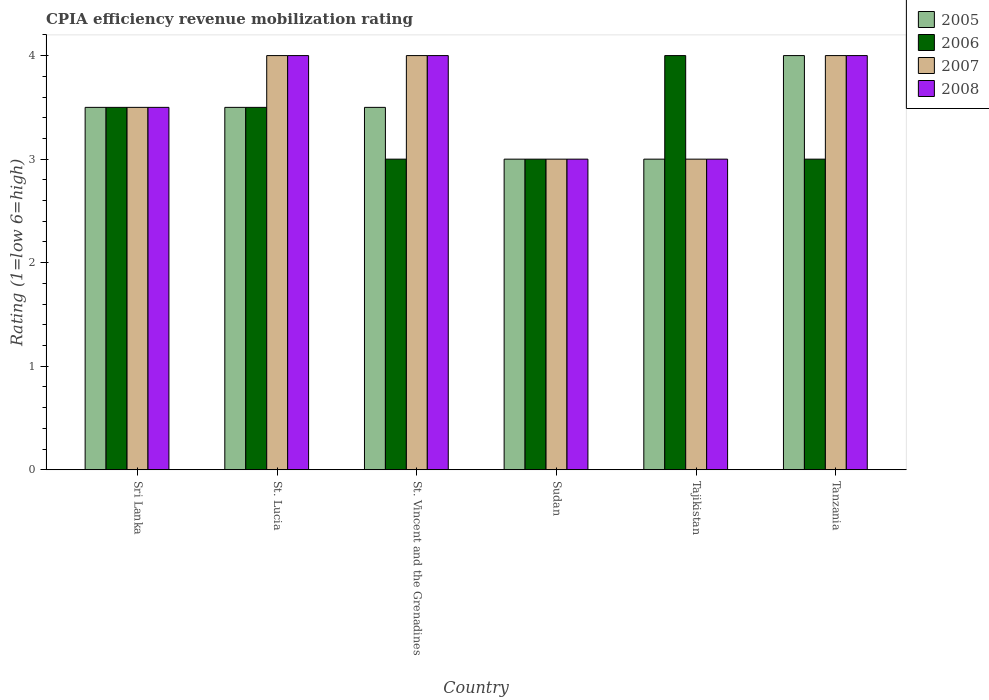Are the number of bars on each tick of the X-axis equal?
Give a very brief answer. Yes. How many bars are there on the 4th tick from the right?
Provide a short and direct response. 4. What is the label of the 2nd group of bars from the left?
Make the answer very short. St. Lucia. In which country was the CPIA rating in 2006 maximum?
Your answer should be very brief. Tajikistan. In which country was the CPIA rating in 2008 minimum?
Give a very brief answer. Sudan. What is the total CPIA rating in 2007 in the graph?
Offer a very short reply. 21.5. What is the difference between the CPIA rating in 2006 in Tajikistan and that in Tanzania?
Give a very brief answer. 1. What is the difference between the CPIA rating in 2005 in Sudan and the CPIA rating in 2008 in Sri Lanka?
Your answer should be compact. -0.5. What is the average CPIA rating in 2008 per country?
Offer a terse response. 3.58. What is the difference between the CPIA rating of/in 2006 and CPIA rating of/in 2007 in Sri Lanka?
Provide a short and direct response. 0. In how many countries, is the CPIA rating in 2006 greater than 2.4?
Make the answer very short. 6. Is the CPIA rating in 2008 in St. Lucia less than that in Tajikistan?
Offer a very short reply. No. Is the difference between the CPIA rating in 2006 in Sudan and Tajikistan greater than the difference between the CPIA rating in 2007 in Sudan and Tajikistan?
Your answer should be very brief. No. What is the difference between the highest and the second highest CPIA rating in 2005?
Make the answer very short. -0.5. What is the difference between the highest and the lowest CPIA rating in 2008?
Give a very brief answer. 1. What does the 3rd bar from the left in St. Vincent and the Grenadines represents?
Give a very brief answer. 2007. How many bars are there?
Ensure brevity in your answer.  24. Does the graph contain any zero values?
Ensure brevity in your answer.  No. Does the graph contain grids?
Offer a very short reply. No. How many legend labels are there?
Offer a very short reply. 4. How are the legend labels stacked?
Offer a terse response. Vertical. What is the title of the graph?
Provide a succinct answer. CPIA efficiency revenue mobilization rating. What is the label or title of the Y-axis?
Make the answer very short. Rating (1=low 6=high). What is the Rating (1=low 6=high) in 2006 in Sri Lanka?
Give a very brief answer. 3.5. What is the Rating (1=low 6=high) in 2008 in Sri Lanka?
Ensure brevity in your answer.  3.5. What is the Rating (1=low 6=high) in 2005 in St. Lucia?
Ensure brevity in your answer.  3.5. What is the Rating (1=low 6=high) of 2006 in St. Lucia?
Keep it short and to the point. 3.5. What is the Rating (1=low 6=high) of 2005 in St. Vincent and the Grenadines?
Offer a terse response. 3.5. What is the Rating (1=low 6=high) in 2006 in St. Vincent and the Grenadines?
Make the answer very short. 3. What is the Rating (1=low 6=high) of 2007 in St. Vincent and the Grenadines?
Make the answer very short. 4. What is the Rating (1=low 6=high) in 2007 in Sudan?
Offer a very short reply. 3. What is the Rating (1=low 6=high) of 2005 in Tajikistan?
Give a very brief answer. 3. What is the Rating (1=low 6=high) in 2005 in Tanzania?
Your answer should be very brief. 4. Across all countries, what is the minimum Rating (1=low 6=high) in 2005?
Offer a very short reply. 3. Across all countries, what is the minimum Rating (1=low 6=high) of 2007?
Provide a short and direct response. 3. Across all countries, what is the minimum Rating (1=low 6=high) in 2008?
Your answer should be compact. 3. What is the total Rating (1=low 6=high) in 2005 in the graph?
Your answer should be compact. 20.5. What is the total Rating (1=low 6=high) in 2006 in the graph?
Offer a very short reply. 20. What is the difference between the Rating (1=low 6=high) in 2005 in Sri Lanka and that in St. Lucia?
Provide a succinct answer. 0. What is the difference between the Rating (1=low 6=high) in 2005 in Sri Lanka and that in St. Vincent and the Grenadines?
Provide a succinct answer. 0. What is the difference between the Rating (1=low 6=high) in 2008 in Sri Lanka and that in St. Vincent and the Grenadines?
Offer a very short reply. -0.5. What is the difference between the Rating (1=low 6=high) in 2006 in Sri Lanka and that in Sudan?
Provide a succinct answer. 0.5. What is the difference between the Rating (1=low 6=high) in 2007 in Sri Lanka and that in Sudan?
Provide a succinct answer. 0.5. What is the difference between the Rating (1=low 6=high) of 2006 in Sri Lanka and that in Tajikistan?
Provide a succinct answer. -0.5. What is the difference between the Rating (1=low 6=high) of 2005 in Sri Lanka and that in Tanzania?
Offer a terse response. -0.5. What is the difference between the Rating (1=low 6=high) in 2006 in Sri Lanka and that in Tanzania?
Provide a short and direct response. 0.5. What is the difference between the Rating (1=low 6=high) of 2008 in Sri Lanka and that in Tanzania?
Your response must be concise. -0.5. What is the difference between the Rating (1=low 6=high) in 2006 in St. Lucia and that in St. Vincent and the Grenadines?
Your answer should be compact. 0.5. What is the difference between the Rating (1=low 6=high) of 2007 in St. Lucia and that in St. Vincent and the Grenadines?
Your answer should be compact. 0. What is the difference between the Rating (1=low 6=high) in 2005 in St. Lucia and that in Sudan?
Your answer should be compact. 0.5. What is the difference between the Rating (1=low 6=high) of 2007 in St. Lucia and that in Sudan?
Offer a terse response. 1. What is the difference between the Rating (1=low 6=high) of 2008 in St. Lucia and that in Sudan?
Your answer should be very brief. 1. What is the difference between the Rating (1=low 6=high) of 2006 in St. Lucia and that in Tajikistan?
Your answer should be very brief. -0.5. What is the difference between the Rating (1=low 6=high) of 2006 in St. Lucia and that in Tanzania?
Ensure brevity in your answer.  0.5. What is the difference between the Rating (1=low 6=high) in 2008 in St. Lucia and that in Tanzania?
Provide a short and direct response. 0. What is the difference between the Rating (1=low 6=high) in 2005 in St. Vincent and the Grenadines and that in Tajikistan?
Your response must be concise. 0.5. What is the difference between the Rating (1=low 6=high) of 2006 in St. Vincent and the Grenadines and that in Tajikistan?
Make the answer very short. -1. What is the difference between the Rating (1=low 6=high) of 2008 in St. Vincent and the Grenadines and that in Tajikistan?
Ensure brevity in your answer.  1. What is the difference between the Rating (1=low 6=high) of 2007 in St. Vincent and the Grenadines and that in Tanzania?
Your response must be concise. 0. What is the difference between the Rating (1=low 6=high) of 2008 in St. Vincent and the Grenadines and that in Tanzania?
Your answer should be very brief. 0. What is the difference between the Rating (1=low 6=high) of 2005 in Sudan and that in Tajikistan?
Your answer should be compact. 0. What is the difference between the Rating (1=low 6=high) of 2006 in Sudan and that in Tajikistan?
Offer a terse response. -1. What is the difference between the Rating (1=low 6=high) in 2005 in Sudan and that in Tanzania?
Give a very brief answer. -1. What is the difference between the Rating (1=low 6=high) of 2006 in Sudan and that in Tanzania?
Provide a short and direct response. 0. What is the difference between the Rating (1=low 6=high) in 2007 in Sudan and that in Tanzania?
Provide a short and direct response. -1. What is the difference between the Rating (1=low 6=high) of 2005 in Tajikistan and that in Tanzania?
Your response must be concise. -1. What is the difference between the Rating (1=low 6=high) of 2006 in Tajikistan and that in Tanzania?
Offer a very short reply. 1. What is the difference between the Rating (1=low 6=high) in 2008 in Tajikistan and that in Tanzania?
Your answer should be very brief. -1. What is the difference between the Rating (1=low 6=high) of 2005 in Sri Lanka and the Rating (1=low 6=high) of 2006 in St. Lucia?
Give a very brief answer. 0. What is the difference between the Rating (1=low 6=high) of 2007 in Sri Lanka and the Rating (1=low 6=high) of 2008 in St. Lucia?
Provide a short and direct response. -0.5. What is the difference between the Rating (1=low 6=high) in 2005 in Sri Lanka and the Rating (1=low 6=high) in 2008 in St. Vincent and the Grenadines?
Make the answer very short. -0.5. What is the difference between the Rating (1=low 6=high) of 2006 in Sri Lanka and the Rating (1=low 6=high) of 2008 in St. Vincent and the Grenadines?
Make the answer very short. -0.5. What is the difference between the Rating (1=low 6=high) of 2007 in Sri Lanka and the Rating (1=low 6=high) of 2008 in St. Vincent and the Grenadines?
Provide a short and direct response. -0.5. What is the difference between the Rating (1=low 6=high) in 2005 in Sri Lanka and the Rating (1=low 6=high) in 2006 in Sudan?
Your answer should be compact. 0.5. What is the difference between the Rating (1=low 6=high) in 2006 in Sri Lanka and the Rating (1=low 6=high) in 2007 in Sudan?
Keep it short and to the point. 0.5. What is the difference between the Rating (1=low 6=high) of 2006 in Sri Lanka and the Rating (1=low 6=high) of 2008 in Sudan?
Make the answer very short. 0.5. What is the difference between the Rating (1=low 6=high) in 2006 in Sri Lanka and the Rating (1=low 6=high) in 2008 in Tajikistan?
Your answer should be very brief. 0.5. What is the difference between the Rating (1=low 6=high) of 2005 in Sri Lanka and the Rating (1=low 6=high) of 2006 in Tanzania?
Give a very brief answer. 0.5. What is the difference between the Rating (1=low 6=high) of 2005 in Sri Lanka and the Rating (1=low 6=high) of 2007 in Tanzania?
Ensure brevity in your answer.  -0.5. What is the difference between the Rating (1=low 6=high) of 2005 in Sri Lanka and the Rating (1=low 6=high) of 2008 in Tanzania?
Your answer should be very brief. -0.5. What is the difference between the Rating (1=low 6=high) in 2007 in Sri Lanka and the Rating (1=low 6=high) in 2008 in Tanzania?
Offer a terse response. -0.5. What is the difference between the Rating (1=low 6=high) in 2005 in St. Lucia and the Rating (1=low 6=high) in 2006 in St. Vincent and the Grenadines?
Your answer should be very brief. 0.5. What is the difference between the Rating (1=low 6=high) in 2006 in St. Lucia and the Rating (1=low 6=high) in 2007 in St. Vincent and the Grenadines?
Your answer should be very brief. -0.5. What is the difference between the Rating (1=low 6=high) in 2007 in St. Lucia and the Rating (1=low 6=high) in 2008 in Sudan?
Offer a very short reply. 1. What is the difference between the Rating (1=low 6=high) of 2005 in St. Lucia and the Rating (1=low 6=high) of 2006 in Tajikistan?
Your answer should be very brief. -0.5. What is the difference between the Rating (1=low 6=high) of 2005 in St. Lucia and the Rating (1=low 6=high) of 2007 in Tajikistan?
Give a very brief answer. 0.5. What is the difference between the Rating (1=low 6=high) in 2005 in St. Lucia and the Rating (1=low 6=high) in 2008 in Tajikistan?
Offer a very short reply. 0.5. What is the difference between the Rating (1=low 6=high) in 2006 in St. Lucia and the Rating (1=low 6=high) in 2007 in Tajikistan?
Offer a very short reply. 0.5. What is the difference between the Rating (1=low 6=high) in 2006 in St. Lucia and the Rating (1=low 6=high) in 2008 in Tajikistan?
Ensure brevity in your answer.  0.5. What is the difference between the Rating (1=low 6=high) in 2006 in St. Lucia and the Rating (1=low 6=high) in 2007 in Tanzania?
Keep it short and to the point. -0.5. What is the difference between the Rating (1=low 6=high) of 2005 in St. Vincent and the Grenadines and the Rating (1=low 6=high) of 2007 in Sudan?
Your answer should be compact. 0.5. What is the difference between the Rating (1=low 6=high) of 2006 in St. Vincent and the Grenadines and the Rating (1=low 6=high) of 2007 in Sudan?
Your answer should be very brief. 0. What is the difference between the Rating (1=low 6=high) of 2006 in St. Vincent and the Grenadines and the Rating (1=low 6=high) of 2008 in Sudan?
Ensure brevity in your answer.  0. What is the difference between the Rating (1=low 6=high) in 2005 in St. Vincent and the Grenadines and the Rating (1=low 6=high) in 2006 in Tajikistan?
Provide a short and direct response. -0.5. What is the difference between the Rating (1=low 6=high) of 2005 in St. Vincent and the Grenadines and the Rating (1=low 6=high) of 2007 in Tajikistan?
Your response must be concise. 0.5. What is the difference between the Rating (1=low 6=high) in 2006 in St. Vincent and the Grenadines and the Rating (1=low 6=high) in 2007 in Tajikistan?
Provide a short and direct response. 0. What is the difference between the Rating (1=low 6=high) in 2005 in St. Vincent and the Grenadines and the Rating (1=low 6=high) in 2007 in Tanzania?
Your answer should be compact. -0.5. What is the difference between the Rating (1=low 6=high) of 2005 in Sudan and the Rating (1=low 6=high) of 2008 in Tajikistan?
Provide a succinct answer. 0. What is the difference between the Rating (1=low 6=high) in 2007 in Sudan and the Rating (1=low 6=high) in 2008 in Tajikistan?
Ensure brevity in your answer.  0. What is the difference between the Rating (1=low 6=high) in 2005 in Sudan and the Rating (1=low 6=high) in 2007 in Tanzania?
Ensure brevity in your answer.  -1. What is the difference between the Rating (1=low 6=high) in 2006 in Sudan and the Rating (1=low 6=high) in 2007 in Tanzania?
Your answer should be very brief. -1. What is the difference between the Rating (1=low 6=high) in 2005 in Tajikistan and the Rating (1=low 6=high) in 2007 in Tanzania?
Make the answer very short. -1. What is the difference between the Rating (1=low 6=high) of 2005 in Tajikistan and the Rating (1=low 6=high) of 2008 in Tanzania?
Your response must be concise. -1. What is the difference between the Rating (1=low 6=high) in 2006 in Tajikistan and the Rating (1=low 6=high) in 2007 in Tanzania?
Keep it short and to the point. 0. What is the average Rating (1=low 6=high) of 2005 per country?
Offer a terse response. 3.42. What is the average Rating (1=low 6=high) in 2006 per country?
Keep it short and to the point. 3.33. What is the average Rating (1=low 6=high) in 2007 per country?
Offer a terse response. 3.58. What is the average Rating (1=low 6=high) in 2008 per country?
Make the answer very short. 3.58. What is the difference between the Rating (1=low 6=high) in 2005 and Rating (1=low 6=high) in 2008 in Sri Lanka?
Keep it short and to the point. 0. What is the difference between the Rating (1=low 6=high) of 2006 and Rating (1=low 6=high) of 2008 in Sri Lanka?
Ensure brevity in your answer.  0. What is the difference between the Rating (1=low 6=high) in 2007 and Rating (1=low 6=high) in 2008 in Sri Lanka?
Your answer should be very brief. 0. What is the difference between the Rating (1=low 6=high) in 2005 and Rating (1=low 6=high) in 2006 in St. Lucia?
Provide a succinct answer. 0. What is the difference between the Rating (1=low 6=high) in 2005 and Rating (1=low 6=high) in 2008 in St. Lucia?
Offer a terse response. -0.5. What is the difference between the Rating (1=low 6=high) in 2005 and Rating (1=low 6=high) in 2006 in St. Vincent and the Grenadines?
Provide a succinct answer. 0.5. What is the difference between the Rating (1=low 6=high) in 2005 and Rating (1=low 6=high) in 2008 in St. Vincent and the Grenadines?
Your answer should be very brief. -0.5. What is the difference between the Rating (1=low 6=high) in 2006 and Rating (1=low 6=high) in 2008 in St. Vincent and the Grenadines?
Provide a succinct answer. -1. What is the difference between the Rating (1=low 6=high) in 2005 and Rating (1=low 6=high) in 2006 in Sudan?
Give a very brief answer. 0. What is the difference between the Rating (1=low 6=high) in 2005 and Rating (1=low 6=high) in 2008 in Sudan?
Your answer should be compact. 0. What is the difference between the Rating (1=low 6=high) in 2006 and Rating (1=low 6=high) in 2007 in Sudan?
Your answer should be very brief. 0. What is the difference between the Rating (1=low 6=high) in 2006 and Rating (1=low 6=high) in 2008 in Sudan?
Your answer should be compact. 0. What is the difference between the Rating (1=low 6=high) of 2007 and Rating (1=low 6=high) of 2008 in Sudan?
Offer a terse response. 0. What is the difference between the Rating (1=low 6=high) of 2005 and Rating (1=low 6=high) of 2007 in Tajikistan?
Ensure brevity in your answer.  0. What is the difference between the Rating (1=low 6=high) in 2005 and Rating (1=low 6=high) in 2008 in Tajikistan?
Give a very brief answer. 0. What is the difference between the Rating (1=low 6=high) of 2006 and Rating (1=low 6=high) of 2007 in Tajikistan?
Keep it short and to the point. 1. What is the difference between the Rating (1=low 6=high) of 2006 and Rating (1=low 6=high) of 2008 in Tajikistan?
Your response must be concise. 1. What is the difference between the Rating (1=low 6=high) of 2007 and Rating (1=low 6=high) of 2008 in Tajikistan?
Your answer should be compact. 0. What is the difference between the Rating (1=low 6=high) in 2005 and Rating (1=low 6=high) in 2006 in Tanzania?
Ensure brevity in your answer.  1. What is the difference between the Rating (1=low 6=high) in 2005 and Rating (1=low 6=high) in 2007 in Tanzania?
Provide a succinct answer. 0. What is the difference between the Rating (1=low 6=high) in 2006 and Rating (1=low 6=high) in 2008 in Tanzania?
Offer a terse response. -1. What is the difference between the Rating (1=low 6=high) in 2007 and Rating (1=low 6=high) in 2008 in Tanzania?
Your response must be concise. 0. What is the ratio of the Rating (1=low 6=high) in 2006 in Sri Lanka to that in St. Lucia?
Your response must be concise. 1. What is the ratio of the Rating (1=low 6=high) of 2007 in Sri Lanka to that in St. Lucia?
Provide a short and direct response. 0.88. What is the ratio of the Rating (1=low 6=high) of 2008 in Sri Lanka to that in St. Lucia?
Provide a succinct answer. 0.88. What is the ratio of the Rating (1=low 6=high) of 2007 in Sri Lanka to that in St. Vincent and the Grenadines?
Make the answer very short. 0.88. What is the ratio of the Rating (1=low 6=high) in 2006 in Sri Lanka to that in Sudan?
Provide a succinct answer. 1.17. What is the ratio of the Rating (1=low 6=high) of 2007 in Sri Lanka to that in Sudan?
Offer a terse response. 1.17. What is the ratio of the Rating (1=low 6=high) in 2007 in Sri Lanka to that in Tajikistan?
Offer a very short reply. 1.17. What is the ratio of the Rating (1=low 6=high) of 2006 in Sri Lanka to that in Tanzania?
Your answer should be compact. 1.17. What is the ratio of the Rating (1=low 6=high) in 2007 in Sri Lanka to that in Tanzania?
Provide a succinct answer. 0.88. What is the ratio of the Rating (1=low 6=high) of 2005 in St. Lucia to that in St. Vincent and the Grenadines?
Offer a terse response. 1. What is the ratio of the Rating (1=low 6=high) in 2007 in St. Lucia to that in St. Vincent and the Grenadines?
Your response must be concise. 1. What is the ratio of the Rating (1=low 6=high) in 2008 in St. Lucia to that in St. Vincent and the Grenadines?
Your answer should be compact. 1. What is the ratio of the Rating (1=low 6=high) of 2005 in St. Lucia to that in Sudan?
Your answer should be compact. 1.17. What is the ratio of the Rating (1=low 6=high) in 2007 in St. Lucia to that in Sudan?
Provide a succinct answer. 1.33. What is the ratio of the Rating (1=low 6=high) of 2005 in St. Lucia to that in Tajikistan?
Offer a very short reply. 1.17. What is the ratio of the Rating (1=low 6=high) of 2008 in St. Lucia to that in Tajikistan?
Give a very brief answer. 1.33. What is the ratio of the Rating (1=low 6=high) of 2005 in St. Lucia to that in Tanzania?
Your answer should be very brief. 0.88. What is the ratio of the Rating (1=low 6=high) of 2006 in St. Lucia to that in Tanzania?
Provide a succinct answer. 1.17. What is the ratio of the Rating (1=low 6=high) of 2008 in St. Lucia to that in Tanzania?
Provide a short and direct response. 1. What is the ratio of the Rating (1=low 6=high) of 2006 in St. Vincent and the Grenadines to that in Sudan?
Keep it short and to the point. 1. What is the ratio of the Rating (1=low 6=high) in 2008 in St. Vincent and the Grenadines to that in Sudan?
Ensure brevity in your answer.  1.33. What is the ratio of the Rating (1=low 6=high) of 2005 in St. Vincent and the Grenadines to that in Tajikistan?
Provide a short and direct response. 1.17. What is the ratio of the Rating (1=low 6=high) of 2006 in St. Vincent and the Grenadines to that in Tajikistan?
Offer a very short reply. 0.75. What is the ratio of the Rating (1=low 6=high) in 2007 in St. Vincent and the Grenadines to that in Tajikistan?
Your answer should be very brief. 1.33. What is the ratio of the Rating (1=low 6=high) in 2005 in Sudan to that in Tajikistan?
Give a very brief answer. 1. What is the ratio of the Rating (1=low 6=high) in 2007 in Sudan to that in Tajikistan?
Give a very brief answer. 1. What is the ratio of the Rating (1=low 6=high) in 2008 in Sudan to that in Tajikistan?
Offer a terse response. 1. What is the ratio of the Rating (1=low 6=high) of 2007 in Sudan to that in Tanzania?
Keep it short and to the point. 0.75. What is the ratio of the Rating (1=low 6=high) of 2008 in Sudan to that in Tanzania?
Keep it short and to the point. 0.75. What is the ratio of the Rating (1=low 6=high) in 2006 in Tajikistan to that in Tanzania?
Your answer should be very brief. 1.33. What is the ratio of the Rating (1=low 6=high) of 2008 in Tajikistan to that in Tanzania?
Your answer should be compact. 0.75. What is the difference between the highest and the second highest Rating (1=low 6=high) of 2005?
Keep it short and to the point. 0.5. What is the difference between the highest and the second highest Rating (1=low 6=high) in 2007?
Give a very brief answer. 0. What is the difference between the highest and the second highest Rating (1=low 6=high) in 2008?
Ensure brevity in your answer.  0. What is the difference between the highest and the lowest Rating (1=low 6=high) in 2006?
Provide a succinct answer. 1. What is the difference between the highest and the lowest Rating (1=low 6=high) in 2007?
Ensure brevity in your answer.  1. 